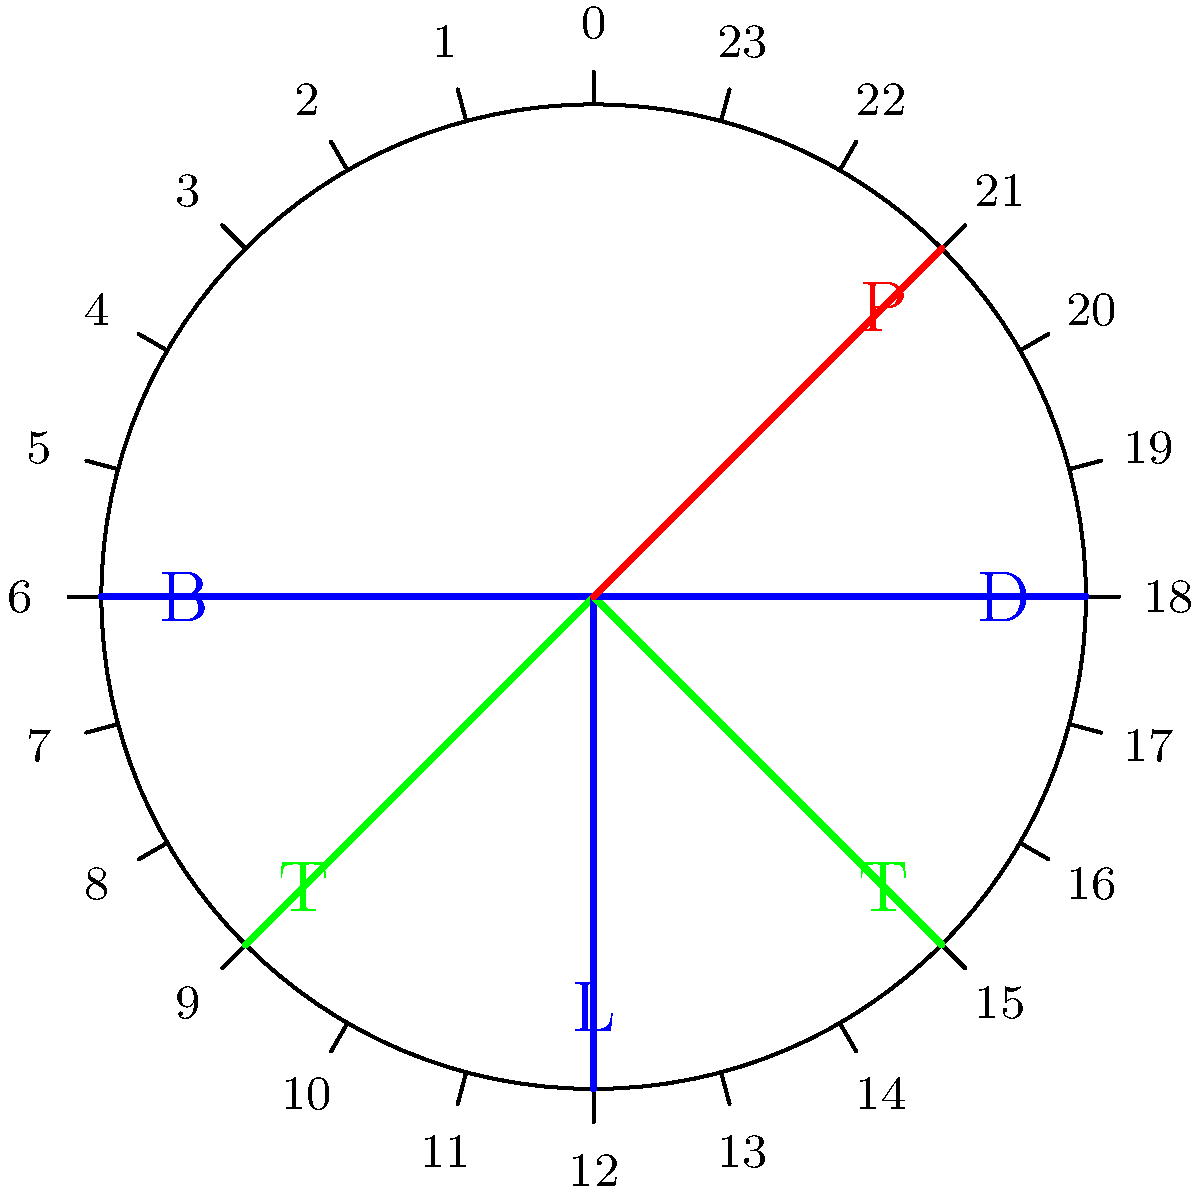As an MMA fighter, you follow a strict nutrient timing schedule. Your day includes breakfast at 6:00 AM, lunch at 12:00 PM, dinner at 6:00 PM, and a protein shake at 9:00 PM. You have two training sessions, one at 9:00 AM and another at 3:00 PM. Each training session lasts for 2 hours. What percentage of your waking hours (assuming you sleep from 10:00 PM to 5:00 AM) is spent either eating meals or training? Let's break this down step-by-step:

1) First, calculate the total waking hours:
   - Sleep time: 10:00 PM to 5:00 AM = 7 hours
   - Waking hours = 24 - 7 = 17 hours

2) Now, let's sum up the time spent on meals and training:
   - Breakfast, lunch, dinner: Assume 30 minutes each = 1.5 hours
   - Protein shake: Assume 15 minutes = 0.25 hours
   - Training sessions: 2 sessions × 2 hours each = 4 hours
   - Total time for meals and training = 1.5 + 0.25 + 4 = 5.75 hours

3) Calculate the percentage:
   $\text{Percentage} = \frac{\text{Time spent on meals and training}}{\text{Total waking hours}} \times 100\%$
   $= \frac{5.75}{17} \times 100\% \approx 33.82\%$

Therefore, approximately 33.82% of your waking hours are spent either eating meals or training.
Answer: 33.82% 